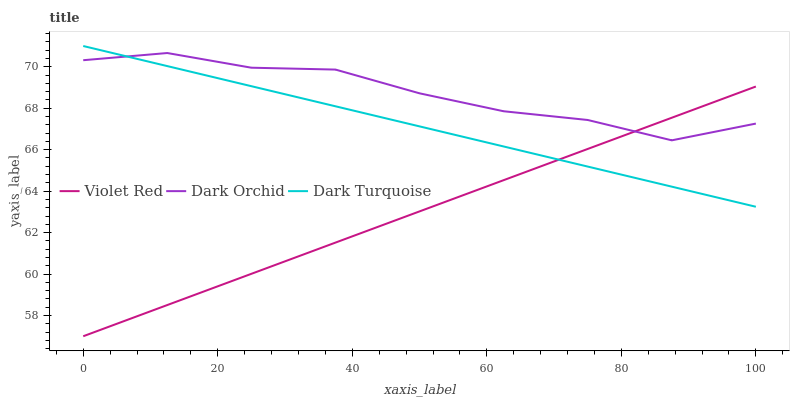Does Violet Red have the minimum area under the curve?
Answer yes or no. Yes. Does Dark Orchid have the maximum area under the curve?
Answer yes or no. Yes. Does Dark Orchid have the minimum area under the curve?
Answer yes or no. No. Does Violet Red have the maximum area under the curve?
Answer yes or no. No. Is Violet Red the smoothest?
Answer yes or no. Yes. Is Dark Orchid the roughest?
Answer yes or no. Yes. Is Dark Orchid the smoothest?
Answer yes or no. No. Is Violet Red the roughest?
Answer yes or no. No. Does Violet Red have the lowest value?
Answer yes or no. Yes. Does Dark Orchid have the lowest value?
Answer yes or no. No. Does Dark Turquoise have the highest value?
Answer yes or no. Yes. Does Dark Orchid have the highest value?
Answer yes or no. No. Does Dark Orchid intersect Violet Red?
Answer yes or no. Yes. Is Dark Orchid less than Violet Red?
Answer yes or no. No. Is Dark Orchid greater than Violet Red?
Answer yes or no. No. 